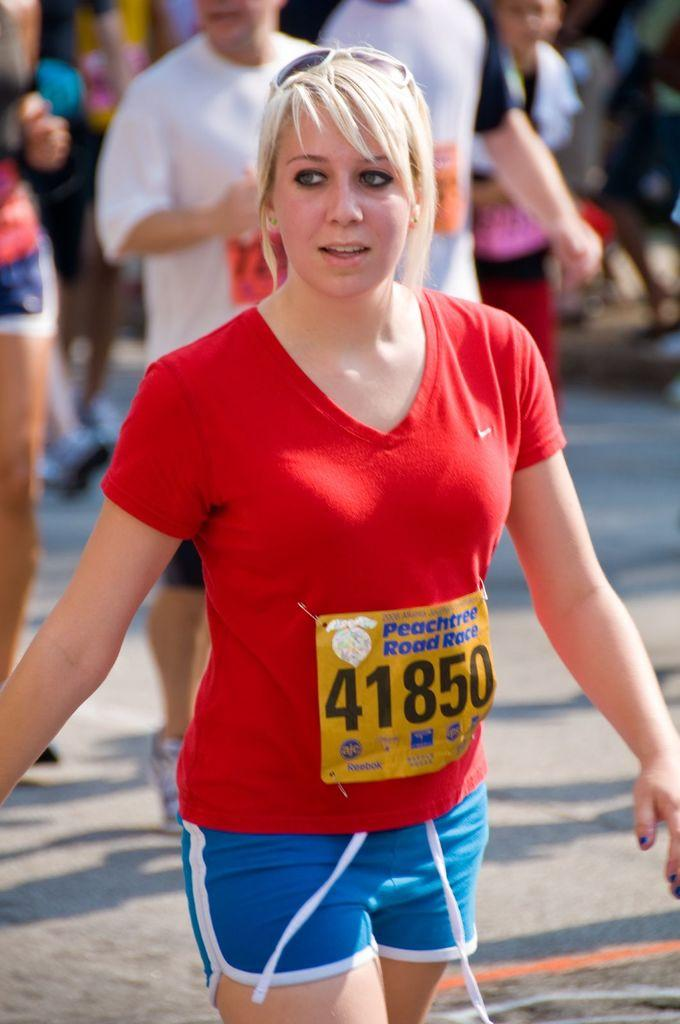Provide a one-sentence caption for the provided image. The lady running this race wears the number 41850. 